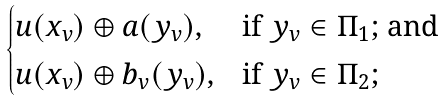<formula> <loc_0><loc_0><loc_500><loc_500>\begin{cases} u ( x _ { v } ) \oplus a ( y _ { v } ) , & \text {if $y_{v}\in\Pi_{1}$; and} \\ u ( x _ { v } ) \oplus b _ { v } ( y _ { v } ) , & \text {if $y_{v}\in\Pi_{2}$;} \end{cases}</formula> 